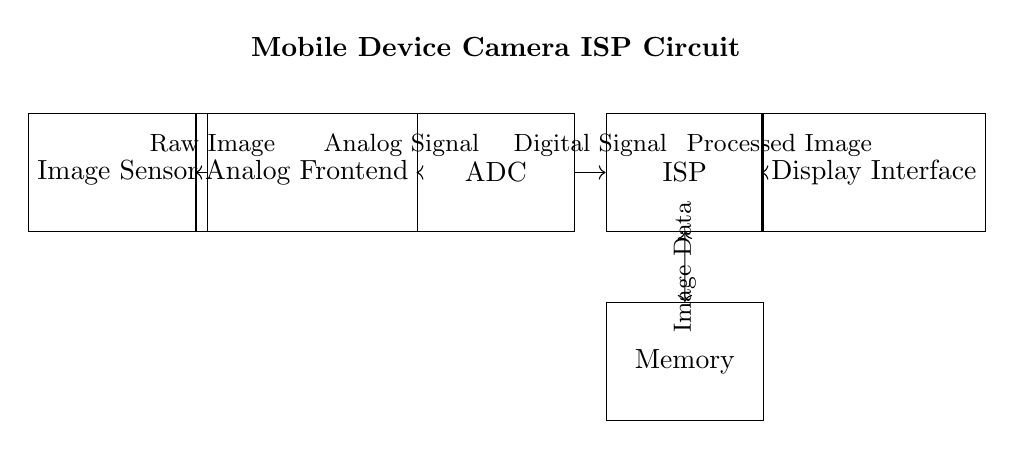What is the first component in the circuit? The first component encountered in the circuit from the left is the Image Sensor, which captures raw images before they are processed.
Answer: Image Sensor What type of signal does the Analog Frontend handle? The Analog Frontend is responsible for handling the Analog Signal output from the Image Sensor. This component prepares the signal for conversion.
Answer: Analog Signal How many connections does the ISP have? The ISP has two connections: one to the ADC (for digital data input) and another to Memory (for data access).
Answer: Two What is the role of the ADC in this circuit? The ADC converts the Analog Signal from the Analog Frontend into a Digital Signal, which is necessary for digital processing.
Answer: Conversion Which component receives the processed image? The component that receives the processed image from the ISP is the Display Interface, which likely presents the final output to the user.
Answer: Display Interface Explain the function of the Memory in this circuit. Memory serves as a storage element for the image data being processed, allowing the ISP to retrieve and read data when needed. This flexibility enhances performance during image processing tasks.
Answer: Storage What is the last output stage of this ISP circuit? The last output stage where processed data is sent is the Display Interface, which presents the final processed image after going through all components.
Answer: Display Interface 